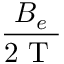Convert formula to latex. <formula><loc_0><loc_0><loc_500><loc_500>\frac { B _ { e } } { 2 T }</formula> 